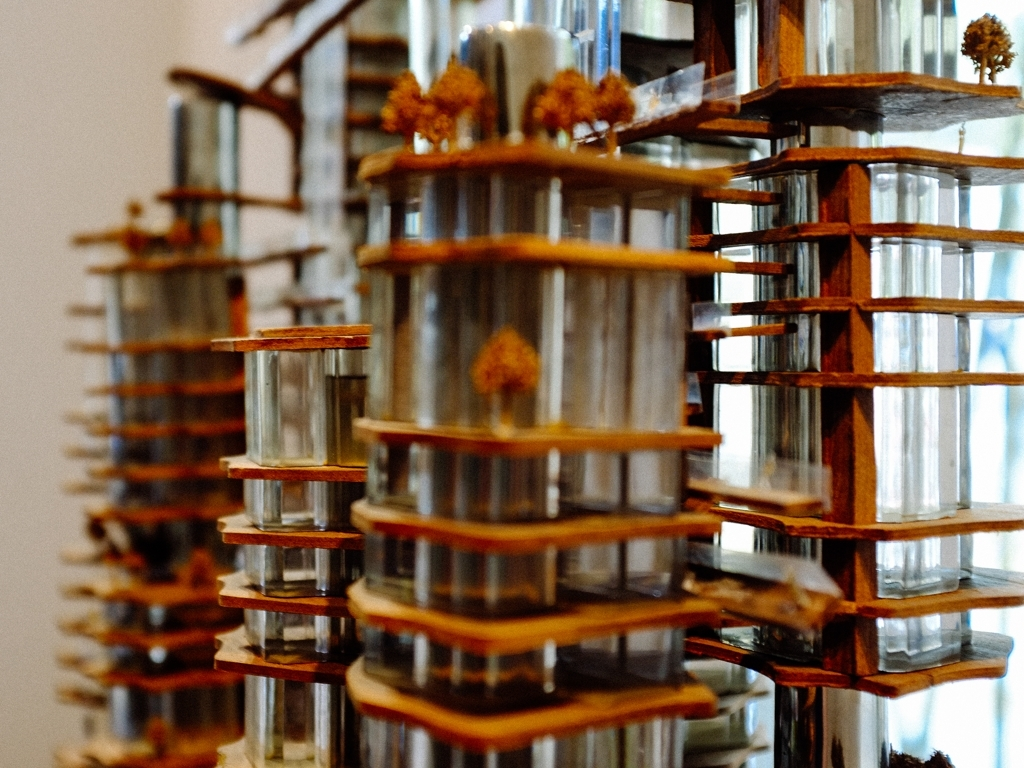Is the quality of this image below average? The image appears to be of average quality in terms of resolution and clarity. It shows a creatively designed structure with a series of repeating elements, and while the focus is sharp in the foreground, the background elements exhibit a soft bokeh which suggests this was an intentional artistic choice rather than an indication of low-quality imaging. 